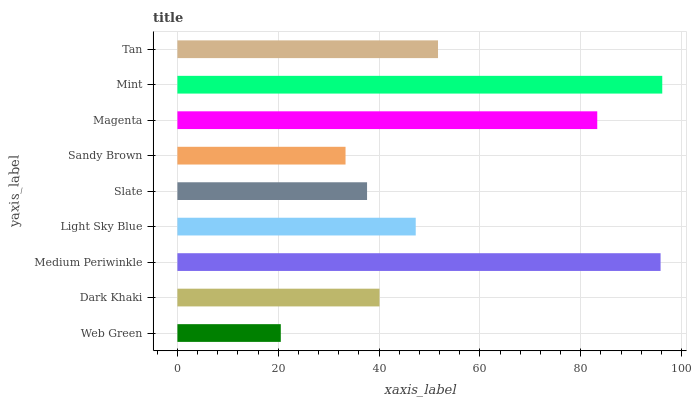Is Web Green the minimum?
Answer yes or no. Yes. Is Mint the maximum?
Answer yes or no. Yes. Is Dark Khaki the minimum?
Answer yes or no. No. Is Dark Khaki the maximum?
Answer yes or no. No. Is Dark Khaki greater than Web Green?
Answer yes or no. Yes. Is Web Green less than Dark Khaki?
Answer yes or no. Yes. Is Web Green greater than Dark Khaki?
Answer yes or no. No. Is Dark Khaki less than Web Green?
Answer yes or no. No. Is Light Sky Blue the high median?
Answer yes or no. Yes. Is Light Sky Blue the low median?
Answer yes or no. Yes. Is Slate the high median?
Answer yes or no. No. Is Slate the low median?
Answer yes or no. No. 